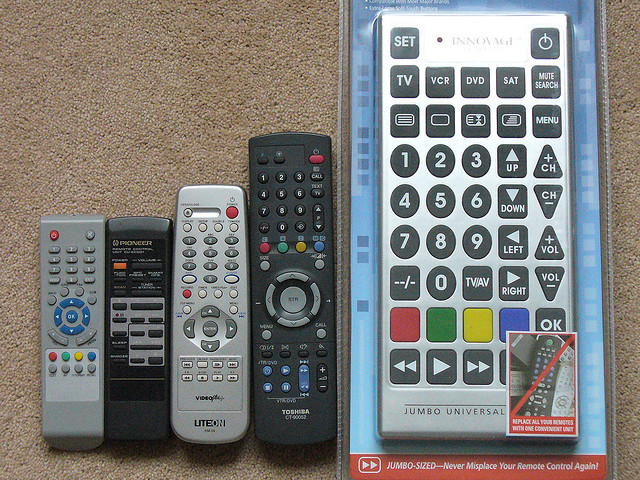Please transcribe the text in this image. VCR DVD SAT MUTE MENU 06 O 9 8 7 G 5 4 3 2 1 PIONEER UTE TOSHIBA Agaln Control Remote Your Misplace -Never JUMBO-SIZED INNOVAGI SEARCS UNIVERSAL JUMBO OK TV/AV RIGHT VOL VOL LEFT DOWN CH CH UP 9 8 7 6 5 4 3 2 1 TV SET 